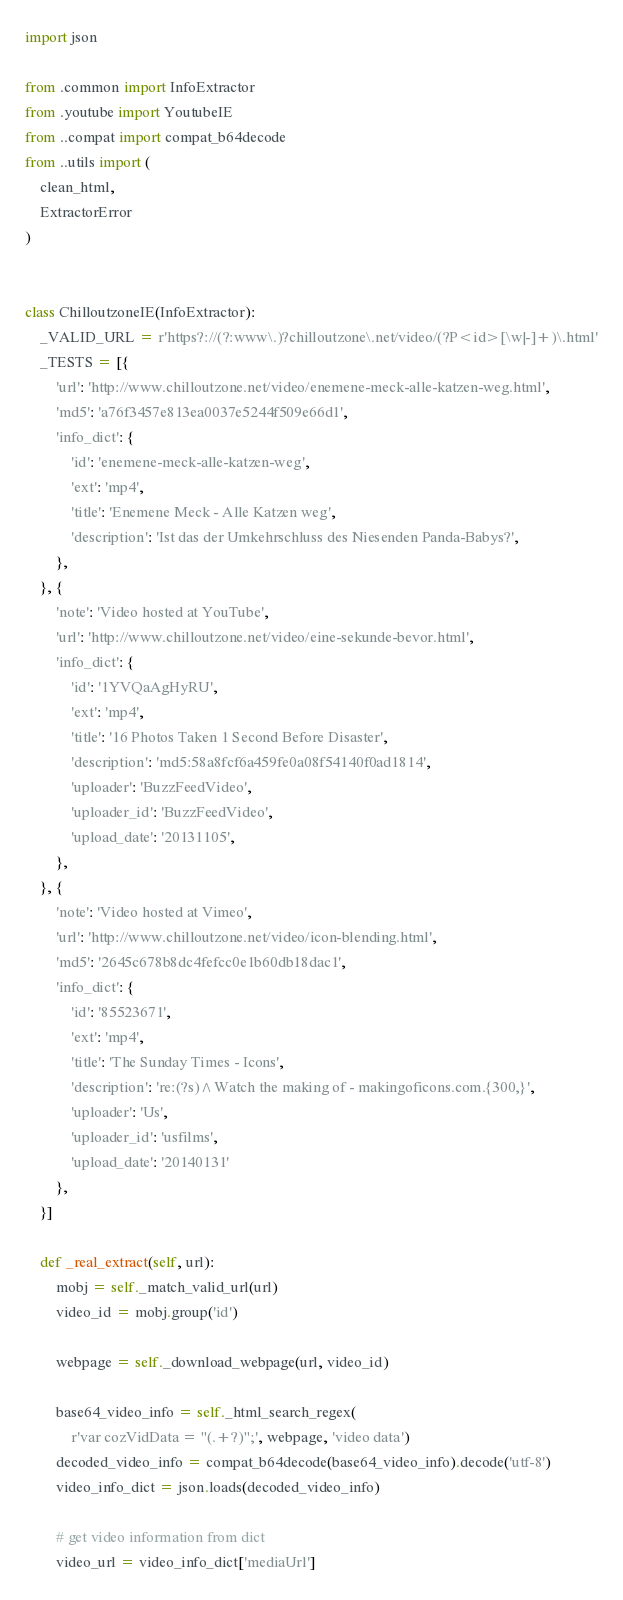Convert code to text. <code><loc_0><loc_0><loc_500><loc_500><_Python_>import json

from .common import InfoExtractor
from .youtube import YoutubeIE
from ..compat import compat_b64decode
from ..utils import (
    clean_html,
    ExtractorError
)


class ChilloutzoneIE(InfoExtractor):
    _VALID_URL = r'https?://(?:www\.)?chilloutzone\.net/video/(?P<id>[\w|-]+)\.html'
    _TESTS = [{
        'url': 'http://www.chilloutzone.net/video/enemene-meck-alle-katzen-weg.html',
        'md5': 'a76f3457e813ea0037e5244f509e66d1',
        'info_dict': {
            'id': 'enemene-meck-alle-katzen-weg',
            'ext': 'mp4',
            'title': 'Enemene Meck - Alle Katzen weg',
            'description': 'Ist das der Umkehrschluss des Niesenden Panda-Babys?',
        },
    }, {
        'note': 'Video hosted at YouTube',
        'url': 'http://www.chilloutzone.net/video/eine-sekunde-bevor.html',
        'info_dict': {
            'id': '1YVQaAgHyRU',
            'ext': 'mp4',
            'title': '16 Photos Taken 1 Second Before Disaster',
            'description': 'md5:58a8fcf6a459fe0a08f54140f0ad1814',
            'uploader': 'BuzzFeedVideo',
            'uploader_id': 'BuzzFeedVideo',
            'upload_date': '20131105',
        },
    }, {
        'note': 'Video hosted at Vimeo',
        'url': 'http://www.chilloutzone.net/video/icon-blending.html',
        'md5': '2645c678b8dc4fefcc0e1b60db18dac1',
        'info_dict': {
            'id': '85523671',
            'ext': 'mp4',
            'title': 'The Sunday Times - Icons',
            'description': 're:(?s)^Watch the making of - makingoficons.com.{300,}',
            'uploader': 'Us',
            'uploader_id': 'usfilms',
            'upload_date': '20140131'
        },
    }]

    def _real_extract(self, url):
        mobj = self._match_valid_url(url)
        video_id = mobj.group('id')

        webpage = self._download_webpage(url, video_id)

        base64_video_info = self._html_search_regex(
            r'var cozVidData = "(.+?)";', webpage, 'video data')
        decoded_video_info = compat_b64decode(base64_video_info).decode('utf-8')
        video_info_dict = json.loads(decoded_video_info)

        # get video information from dict
        video_url = video_info_dict['mediaUrl']</code> 